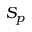Convert formula to latex. <formula><loc_0><loc_0><loc_500><loc_500>S _ { p }</formula> 